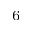Convert formula to latex. <formula><loc_0><loc_0><loc_500><loc_500>{ _ { 6 } }</formula> 